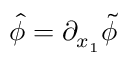<formula> <loc_0><loc_0><loc_500><loc_500>\hat { \phi } = \partial _ { x _ { 1 } } \tilde { \phi }</formula> 